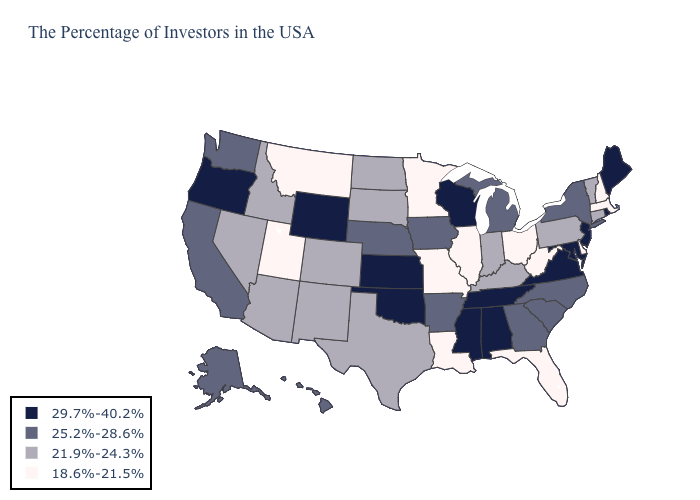Among the states that border Connecticut , does Massachusetts have the highest value?
Short answer required. No. What is the value of Florida?
Concise answer only. 18.6%-21.5%. Which states hav the highest value in the Northeast?
Answer briefly. Maine, Rhode Island, New Jersey. Name the states that have a value in the range 29.7%-40.2%?
Quick response, please. Maine, Rhode Island, New Jersey, Maryland, Virginia, Alabama, Tennessee, Wisconsin, Mississippi, Kansas, Oklahoma, Wyoming, Oregon. Which states have the lowest value in the USA?
Concise answer only. Massachusetts, New Hampshire, Delaware, West Virginia, Ohio, Florida, Illinois, Louisiana, Missouri, Minnesota, Utah, Montana. What is the value of Indiana?
Concise answer only. 21.9%-24.3%. Among the states that border Maine , which have the highest value?
Keep it brief. New Hampshire. Does Arizona have the lowest value in the USA?
Give a very brief answer. No. What is the value of South Dakota?
Quick response, please. 21.9%-24.3%. Which states have the lowest value in the USA?
Answer briefly. Massachusetts, New Hampshire, Delaware, West Virginia, Ohio, Florida, Illinois, Louisiana, Missouri, Minnesota, Utah, Montana. Name the states that have a value in the range 25.2%-28.6%?
Be succinct. New York, North Carolina, South Carolina, Georgia, Michigan, Arkansas, Iowa, Nebraska, California, Washington, Alaska, Hawaii. How many symbols are there in the legend?
Give a very brief answer. 4. What is the value of Colorado?
Short answer required. 21.9%-24.3%. 